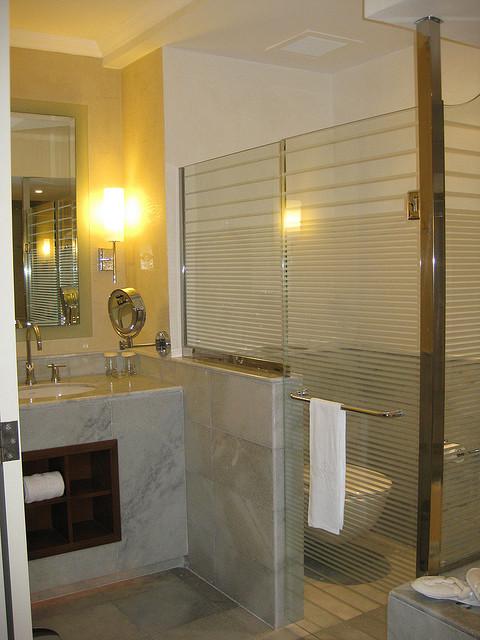Is that a shower behind the glass door?
Answer briefly. No. Is there a light on?
Concise answer only. Yes. What room in the house is this picture?
Keep it brief. Bathroom. 